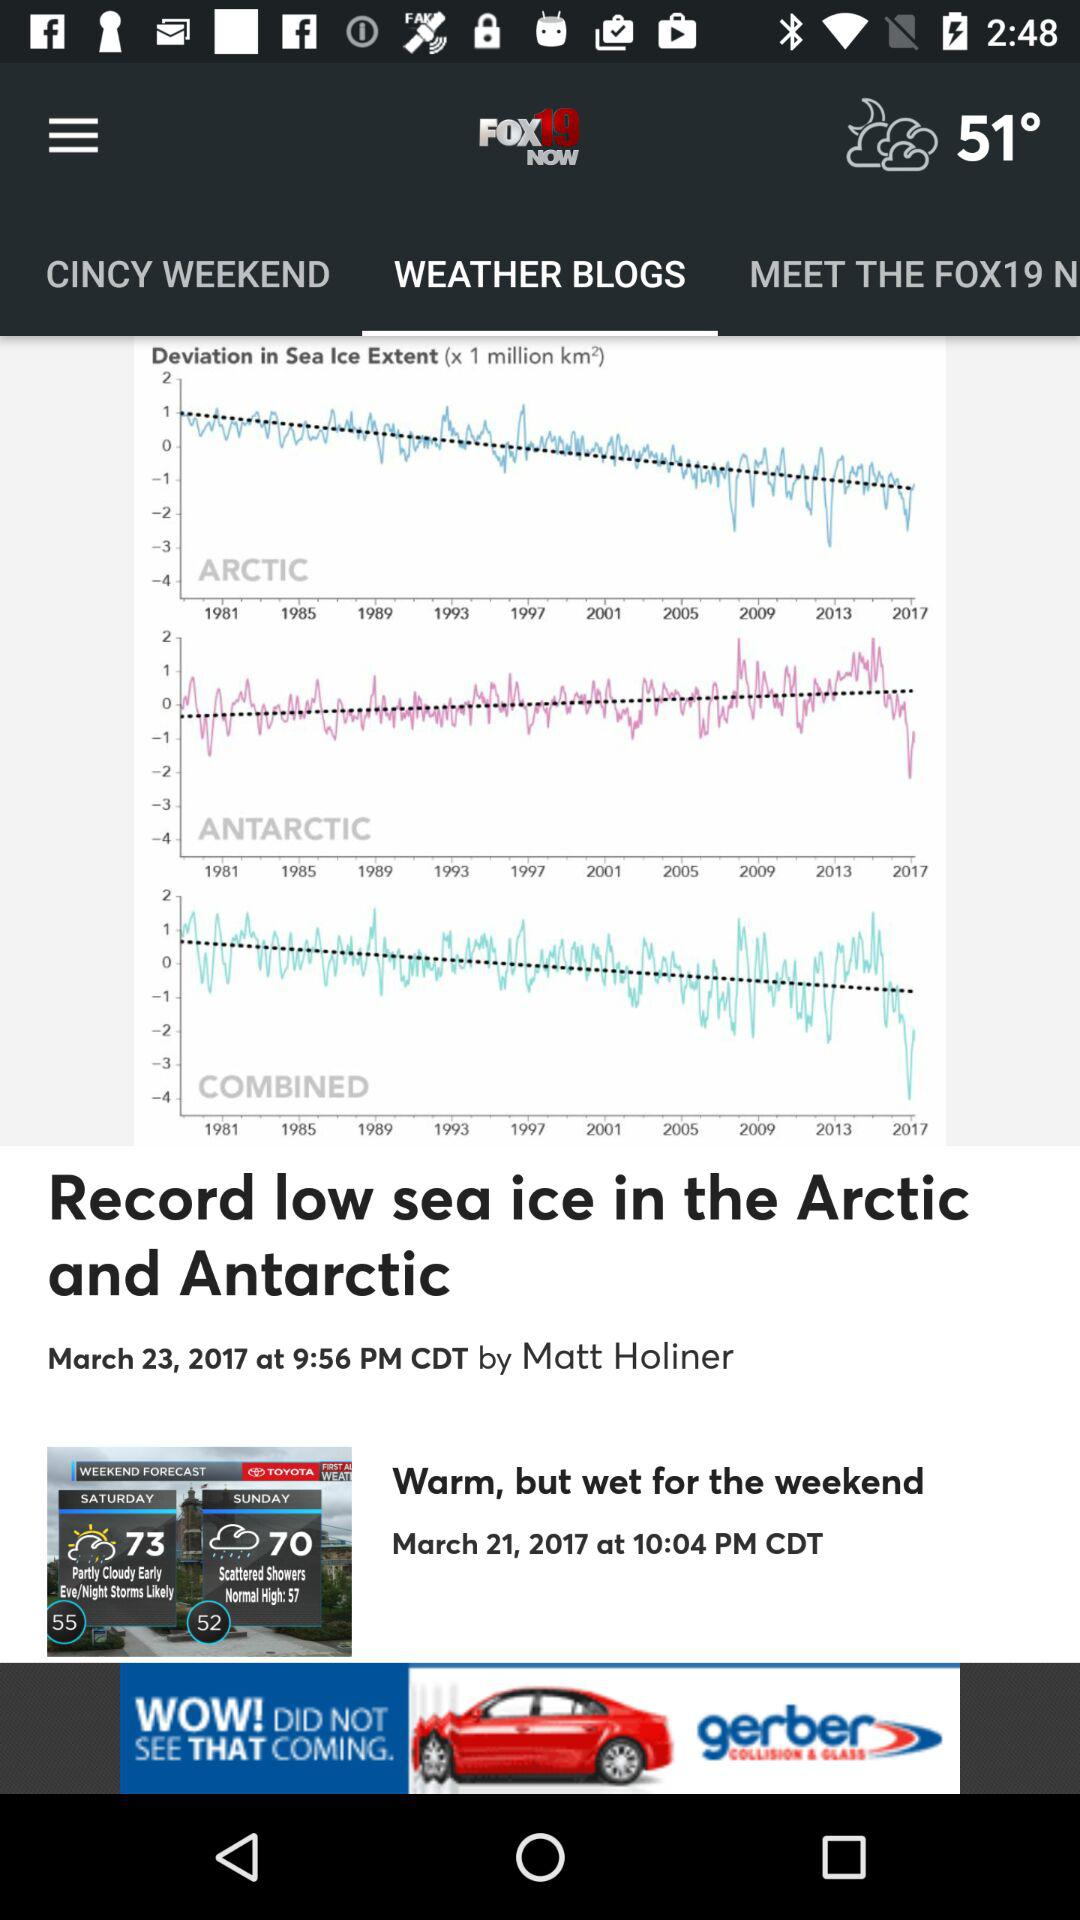Can you tell me more about the sea ice data shown in this image? Certainly! The image displays graphs that represent the deviation in sea ice extent for the Arctic and Antarctic regions over time, as well as a combined graph. This data typically helps scientists and researchers understand trends in sea ice loss or gain, indicating changes in the climate and providing insight into global warming effects. What might be the implications of these trends? The downward trends in both the Arctic and Antarctic sea ice as shown on the graphs could lead to a variety of implications, including rising sea levels, changes in local and global weather patterns, impacts on marine life and ecosystems, and changes in ocean current circulation. These changes can have significant effects on global climate and biodiversity. 